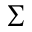<formula> <loc_0><loc_0><loc_500><loc_500>\sum</formula> 